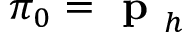<formula> <loc_0><loc_0><loc_500><loc_500>\pi _ { 0 } = p _ { h }</formula> 